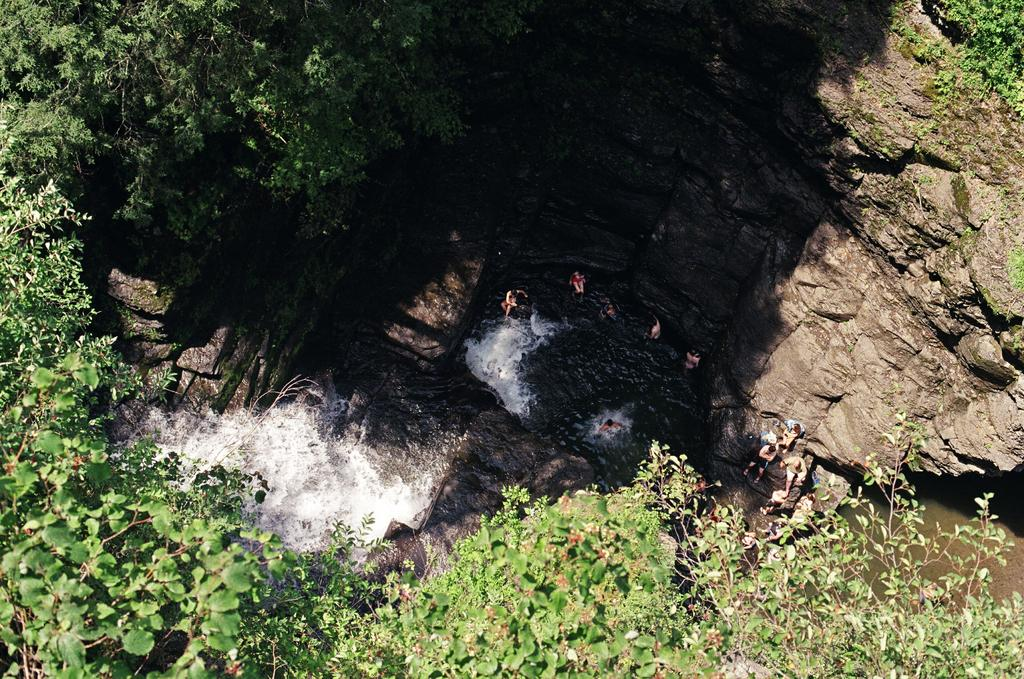What natural feature is the main subject of the image? There is a waterfall in the image. What are the people in the image doing? The people are in the water. What type of vegetation is present around the waterfall? Trees are present around the waterfall. What type of geological feature can be seen in the image? Rocks are visible in the image. What type of steel structure can be seen near the waterfall in the image? There is no steel structure present near the waterfall in the image. What time of day is it in the image, based on the presence of morning light? The time of day cannot be determined from the image, as there is no reference to lighting or shadows that would indicate morning light. 